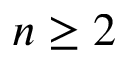<formula> <loc_0><loc_0><loc_500><loc_500>n \geq 2</formula> 